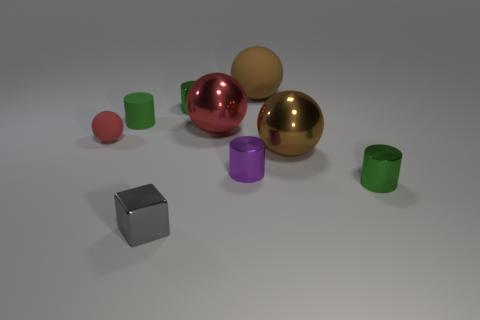How many blue objects are either tiny metallic cylinders or shiny objects?
Offer a very short reply. 0. Is there another shiny block of the same size as the metal cube?
Give a very brief answer. No. What number of small red rubber objects are there?
Your response must be concise. 1. What number of tiny things are either cubes or purple shiny cylinders?
Offer a terse response. 2. There is a rubber object that is behind the tiny green thing on the left side of the small green metal cylinder left of the purple shiny cylinder; what color is it?
Your answer should be compact. Brown. What number of other things are there of the same color as the metal cube?
Offer a very short reply. 0. How many rubber objects are large red things or tiny purple cylinders?
Make the answer very short. 0. There is a small cylinder that is in front of the purple metallic object; does it have the same color as the matte ball that is in front of the big brown matte sphere?
Offer a terse response. No. Is there anything else that is made of the same material as the cube?
Your answer should be very brief. Yes. There is a red rubber thing that is the same shape as the large brown matte object; what size is it?
Offer a very short reply. Small. 